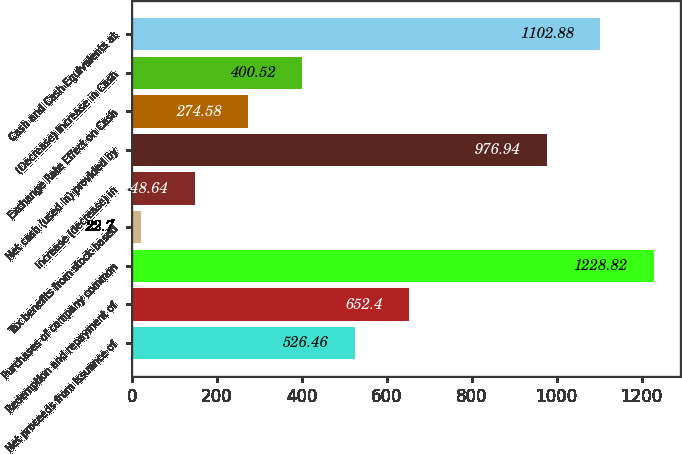Convert chart. <chart><loc_0><loc_0><loc_500><loc_500><bar_chart><fcel>Net proceeds from issuance of<fcel>Redemption and repayment of<fcel>Purchases of company common<fcel>Tax benefits from stock-based<fcel>Increase (decrease) in<fcel>Net cash (used in) provided by<fcel>Exchange Rate Effect on Cash<fcel>(Decrease) Increase in Cash<fcel>Cash and Cash Equivalents at<nl><fcel>526.46<fcel>652.4<fcel>1228.82<fcel>22.7<fcel>148.64<fcel>976.94<fcel>274.58<fcel>400.52<fcel>1102.88<nl></chart> 